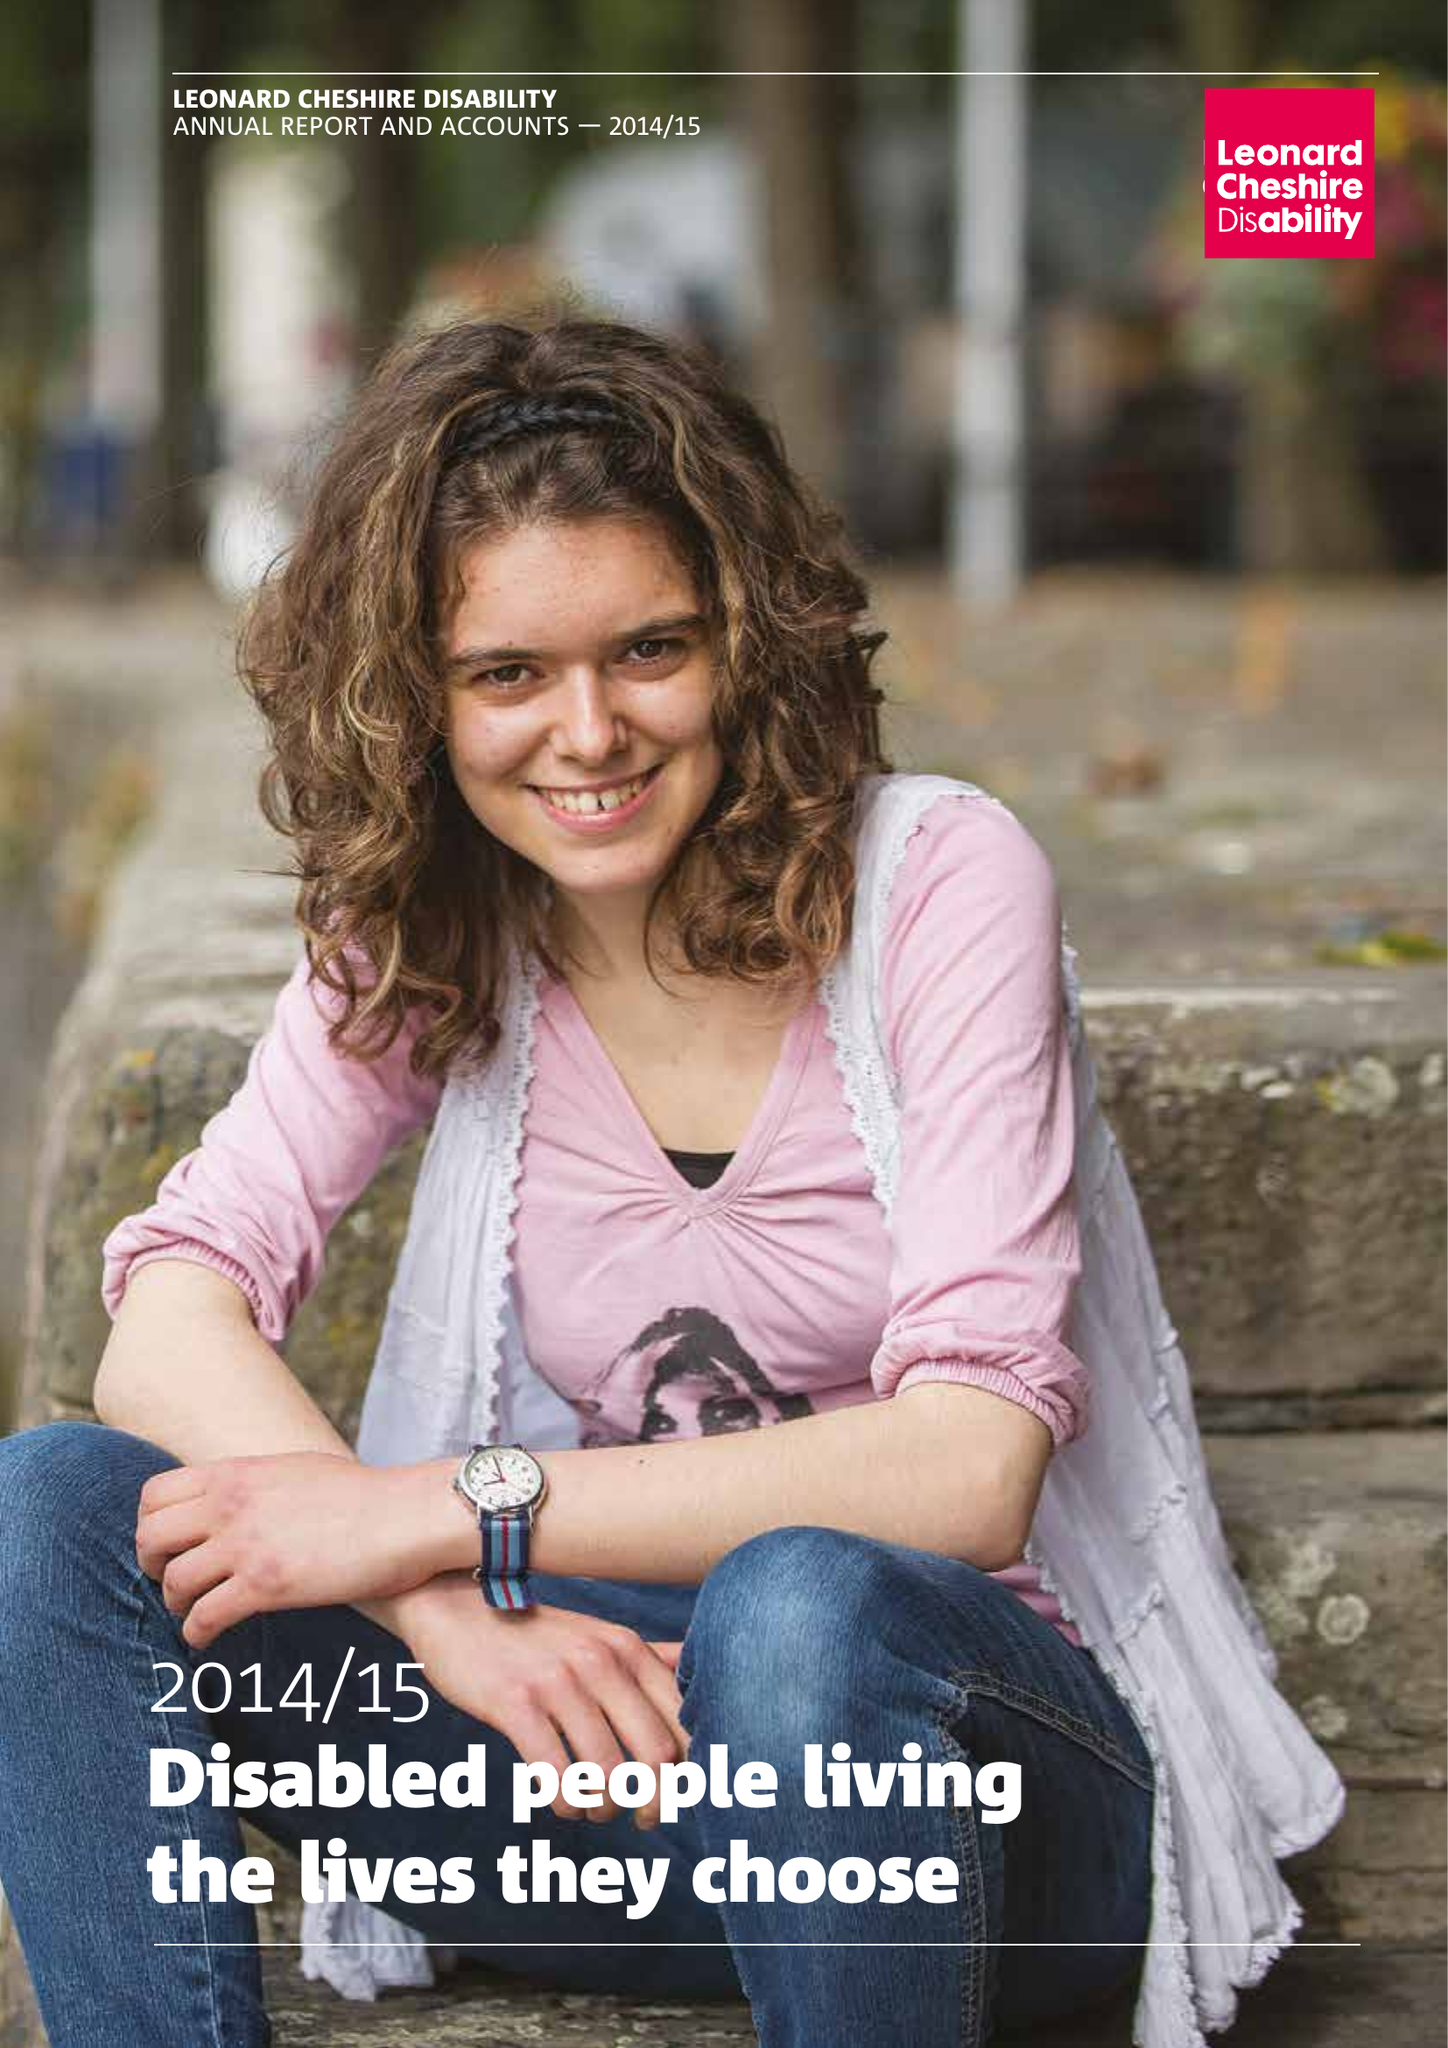What is the value for the spending_annually_in_british_pounds?
Answer the question using a single word or phrase. 156408000.00 